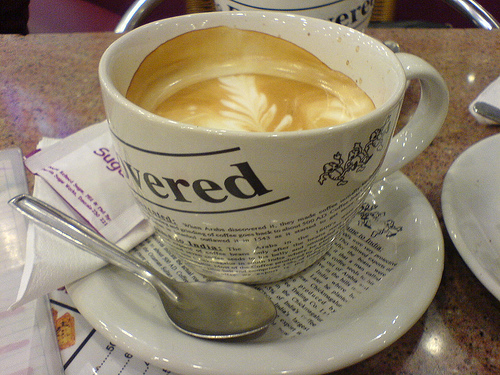<image>
Is the printed words on the cup? Yes. Looking at the image, I can see the printed words is positioned on top of the cup, with the cup providing support. Is there a spoon on the table? No. The spoon is not positioned on the table. They may be near each other, but the spoon is not supported by or resting on top of the table. Is the spoon in the cup? No. The spoon is not contained within the cup. These objects have a different spatial relationship. 